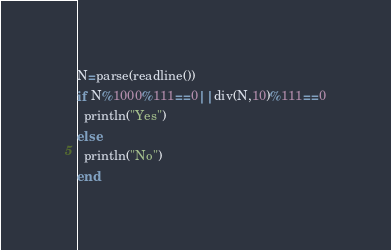Convert code to text. <code><loc_0><loc_0><loc_500><loc_500><_Julia_>N=parse(readline())
if N%1000%111==0||div(N,10)%111==0
  println("Yes")
else
  println("No")
end</code> 